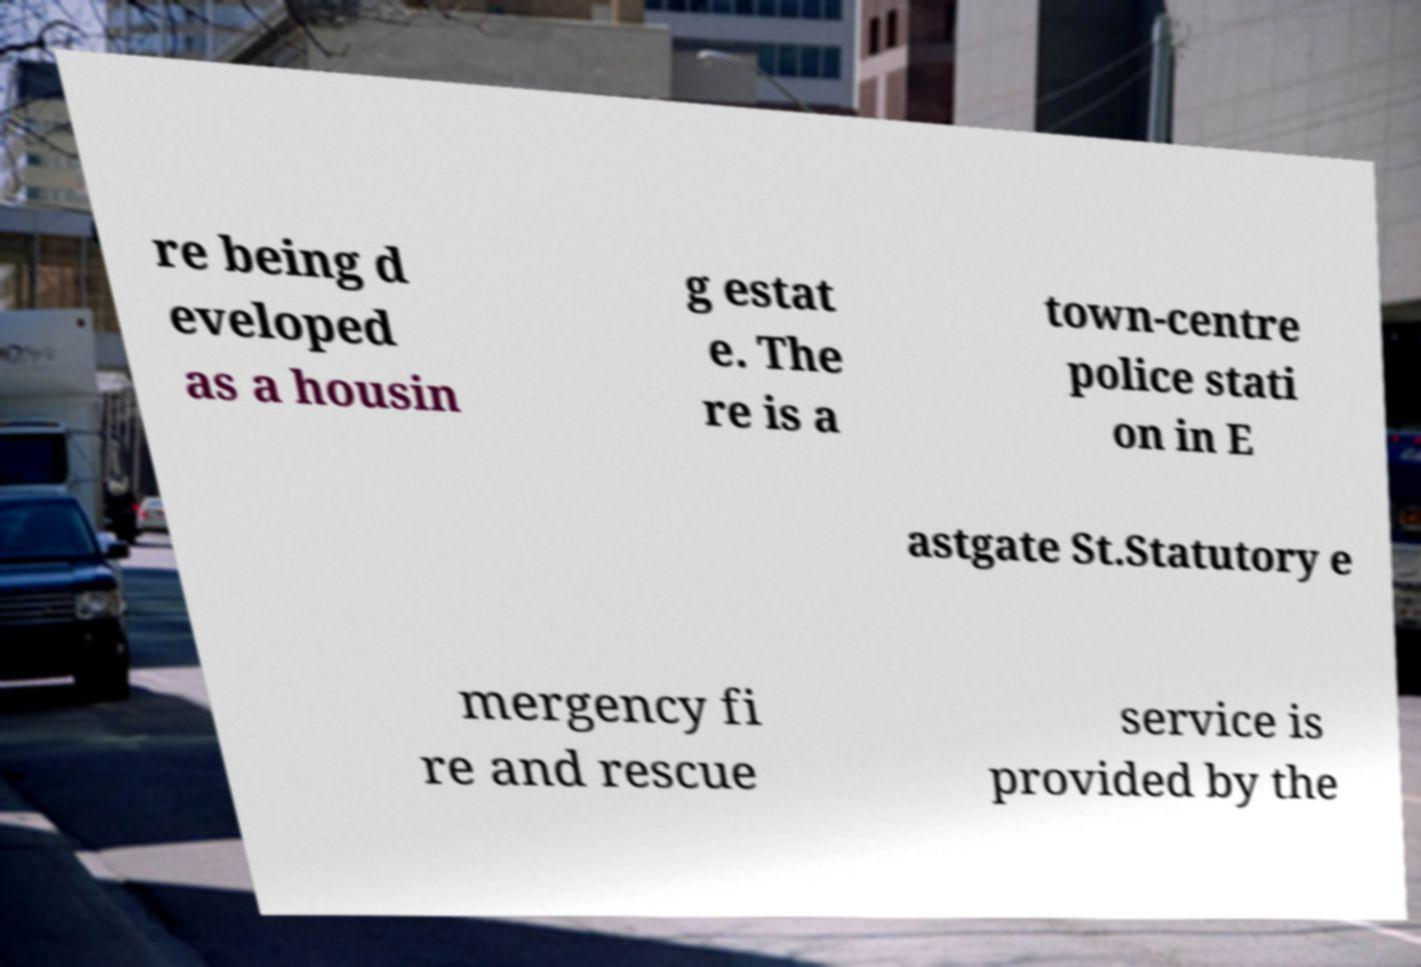Please read and relay the text visible in this image. What does it say? re being d eveloped as a housin g estat e. The re is a town-centre police stati on in E astgate St.Statutory e mergency fi re and rescue service is provided by the 